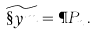<formula> <loc_0><loc_0><loc_500><loc_500>\widetilde { \S y m } = \P P _ { n } \, .</formula> 